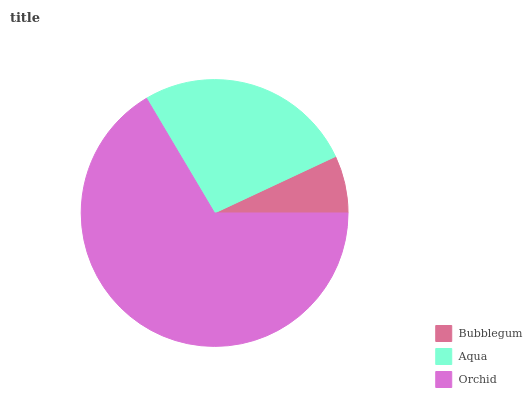Is Bubblegum the minimum?
Answer yes or no. Yes. Is Orchid the maximum?
Answer yes or no. Yes. Is Aqua the minimum?
Answer yes or no. No. Is Aqua the maximum?
Answer yes or no. No. Is Aqua greater than Bubblegum?
Answer yes or no. Yes. Is Bubblegum less than Aqua?
Answer yes or no. Yes. Is Bubblegum greater than Aqua?
Answer yes or no. No. Is Aqua less than Bubblegum?
Answer yes or no. No. Is Aqua the high median?
Answer yes or no. Yes. Is Aqua the low median?
Answer yes or no. Yes. Is Bubblegum the high median?
Answer yes or no. No. Is Orchid the low median?
Answer yes or no. No. 